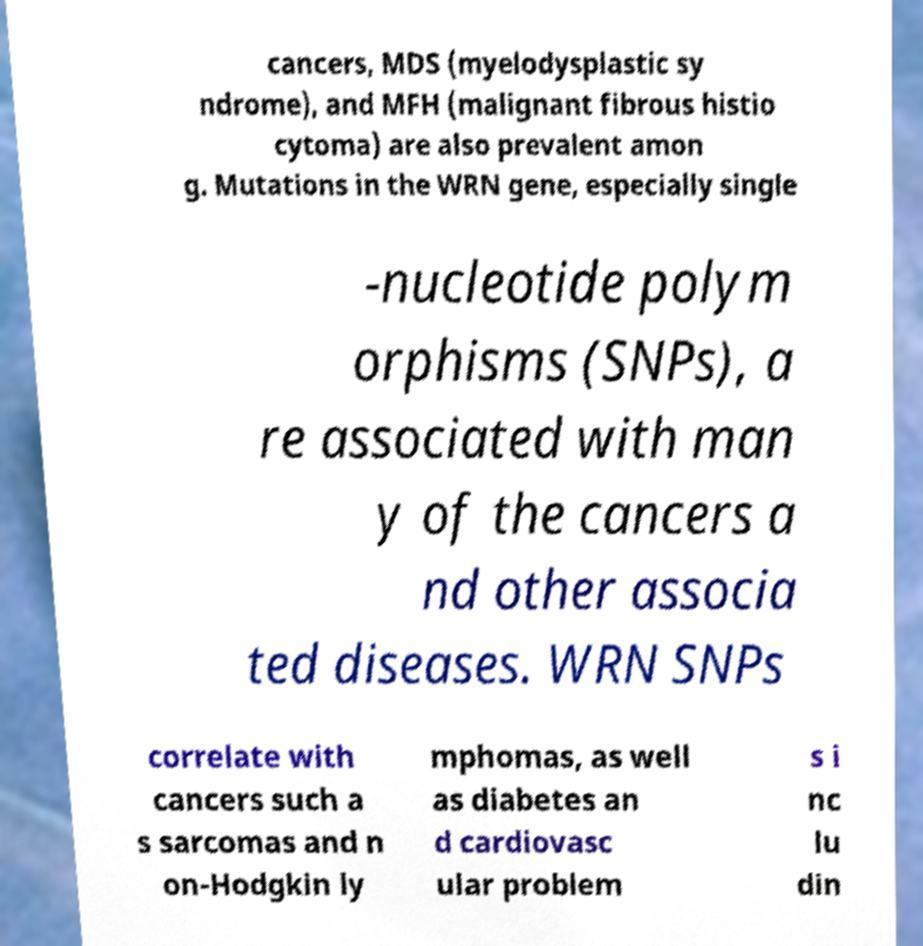What messages or text are displayed in this image? I need them in a readable, typed format. cancers, MDS (myelodysplastic sy ndrome), and MFH (malignant fibrous histio cytoma) are also prevalent amon g. Mutations in the WRN gene, especially single -nucleotide polym orphisms (SNPs), a re associated with man y of the cancers a nd other associa ted diseases. WRN SNPs correlate with cancers such a s sarcomas and n on-Hodgkin ly mphomas, as well as diabetes an d cardiovasc ular problem s i nc lu din 